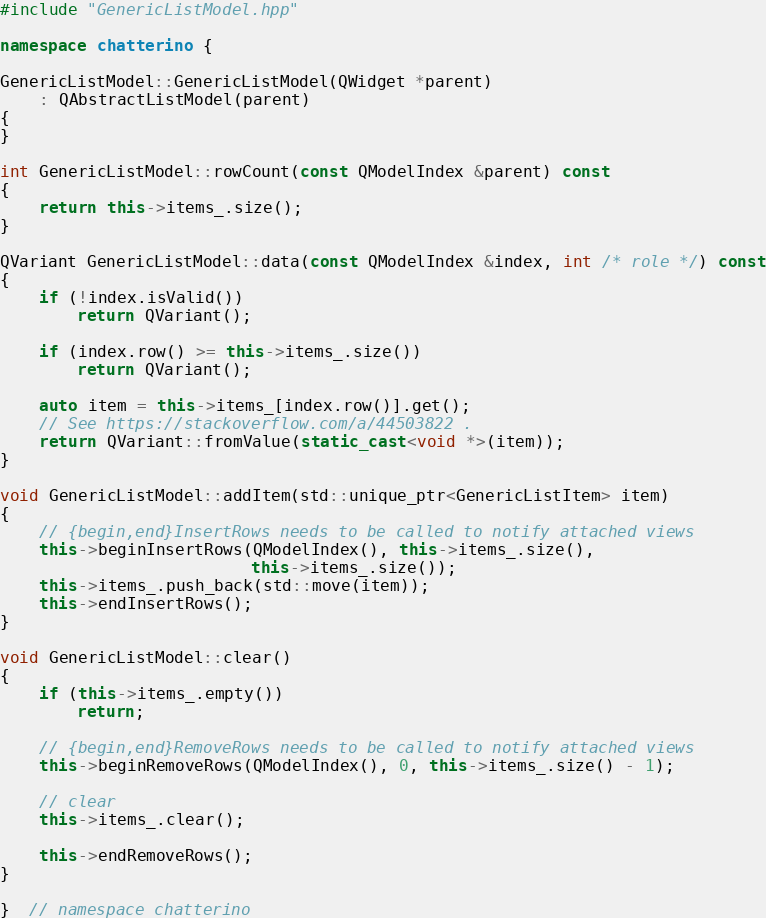Convert code to text. <code><loc_0><loc_0><loc_500><loc_500><_C++_>#include "GenericListModel.hpp"

namespace chatterino {

GenericListModel::GenericListModel(QWidget *parent)
    : QAbstractListModel(parent)
{
}

int GenericListModel::rowCount(const QModelIndex &parent) const
{
    return this->items_.size();
}

QVariant GenericListModel::data(const QModelIndex &index, int /* role */) const
{
    if (!index.isValid())
        return QVariant();

    if (index.row() >= this->items_.size())
        return QVariant();

    auto item = this->items_[index.row()].get();
    // See https://stackoverflow.com/a/44503822 .
    return QVariant::fromValue(static_cast<void *>(item));
}

void GenericListModel::addItem(std::unique_ptr<GenericListItem> item)
{
    // {begin,end}InsertRows needs to be called to notify attached views
    this->beginInsertRows(QModelIndex(), this->items_.size(),
                          this->items_.size());
    this->items_.push_back(std::move(item));
    this->endInsertRows();
}

void GenericListModel::clear()
{
    if (this->items_.empty())
        return;

    // {begin,end}RemoveRows needs to be called to notify attached views
    this->beginRemoveRows(QModelIndex(), 0, this->items_.size() - 1);

    // clear
    this->items_.clear();

    this->endRemoveRows();
}

}  // namespace chatterino
</code> 